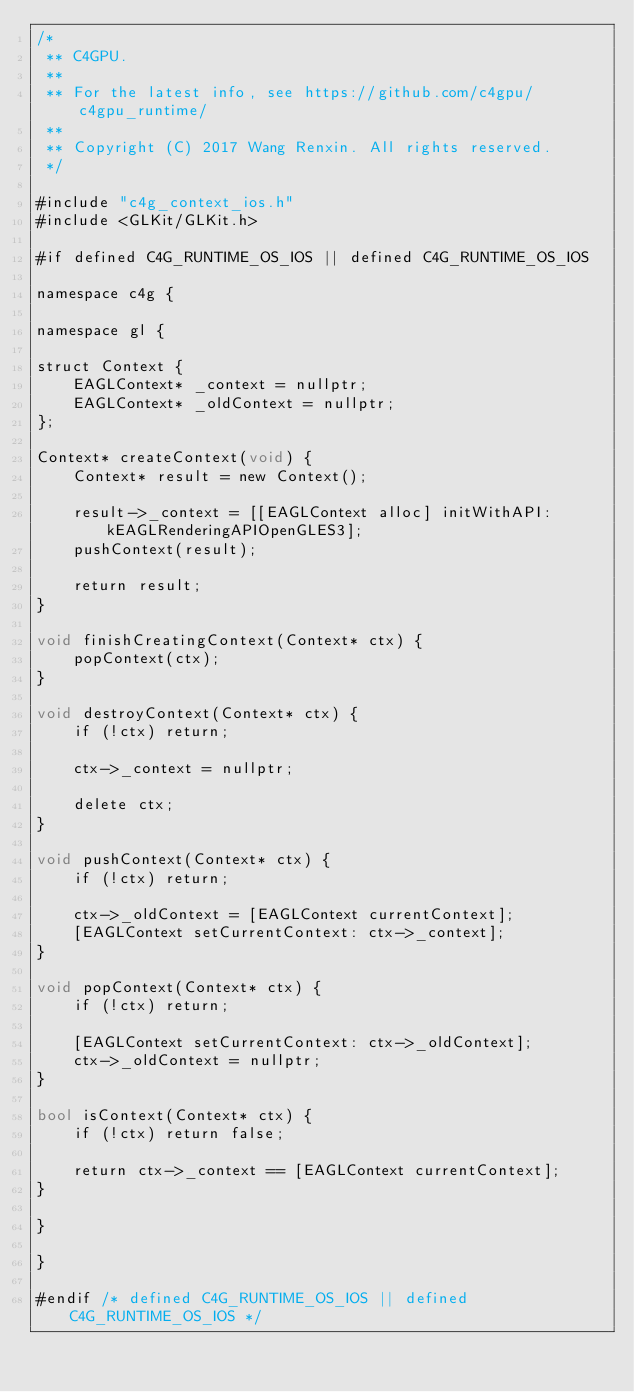<code> <loc_0><loc_0><loc_500><loc_500><_ObjectiveC_>/*
 ** C4GPU.
 **
 ** For the latest info, see https://github.com/c4gpu/c4gpu_runtime/
 **
 ** Copyright (C) 2017 Wang Renxin. All rights reserved.
 */

#include "c4g_context_ios.h"
#include <GLKit/GLKit.h>

#if defined C4G_RUNTIME_OS_IOS || defined C4G_RUNTIME_OS_IOS

namespace c4g {

namespace gl {

struct Context {
	EAGLContext* _context = nullptr;
	EAGLContext* _oldContext = nullptr;
};

Context* createContext(void) {
	Context* result = new Context();

	result->_context = [[EAGLContext alloc] initWithAPI: kEAGLRenderingAPIOpenGLES3];
	pushContext(result);

	return result;
}

void finishCreatingContext(Context* ctx) {
	popContext(ctx);
}

void destroyContext(Context* ctx) {
	if (!ctx) return;

	ctx->_context = nullptr;

	delete ctx;
}

void pushContext(Context* ctx) {
	if (!ctx) return;

	ctx->_oldContext = [EAGLContext currentContext];
	[EAGLContext setCurrentContext: ctx->_context];
}

void popContext(Context* ctx) {
	if (!ctx) return;

	[EAGLContext setCurrentContext: ctx->_oldContext];
	ctx->_oldContext = nullptr;
}

bool isContext(Context* ctx) {
	if (!ctx) return false;

	return ctx->_context == [EAGLContext currentContext];
}

}

}

#endif /* defined C4G_RUNTIME_OS_IOS || defined C4G_RUNTIME_OS_IOS */
</code> 